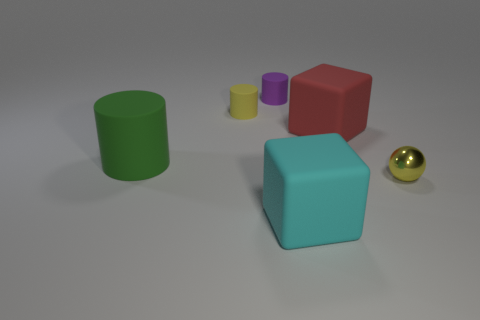Add 3 tiny blue rubber cylinders. How many objects exist? 9 Subtract all cubes. How many objects are left? 4 Subtract 1 green cylinders. How many objects are left? 5 Subtract all purple cylinders. Subtract all tiny spheres. How many objects are left? 4 Add 1 red cubes. How many red cubes are left? 2 Add 3 brown cylinders. How many brown cylinders exist? 3 